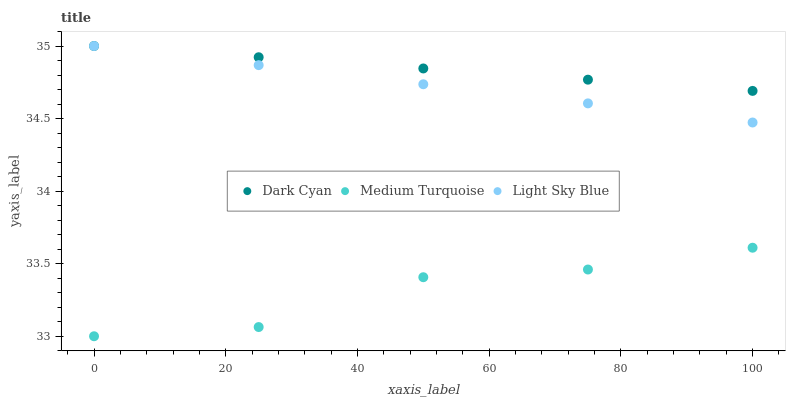Does Medium Turquoise have the minimum area under the curve?
Answer yes or no. Yes. Does Dark Cyan have the maximum area under the curve?
Answer yes or no. Yes. Does Light Sky Blue have the minimum area under the curve?
Answer yes or no. No. Does Light Sky Blue have the maximum area under the curve?
Answer yes or no. No. Is Dark Cyan the smoothest?
Answer yes or no. Yes. Is Medium Turquoise the roughest?
Answer yes or no. Yes. Is Light Sky Blue the smoothest?
Answer yes or no. No. Is Light Sky Blue the roughest?
Answer yes or no. No. Does Medium Turquoise have the lowest value?
Answer yes or no. Yes. Does Light Sky Blue have the lowest value?
Answer yes or no. No. Does Light Sky Blue have the highest value?
Answer yes or no. Yes. Does Medium Turquoise have the highest value?
Answer yes or no. No. Is Medium Turquoise less than Dark Cyan?
Answer yes or no. Yes. Is Dark Cyan greater than Medium Turquoise?
Answer yes or no. Yes. Does Light Sky Blue intersect Dark Cyan?
Answer yes or no. Yes. Is Light Sky Blue less than Dark Cyan?
Answer yes or no. No. Is Light Sky Blue greater than Dark Cyan?
Answer yes or no. No. Does Medium Turquoise intersect Dark Cyan?
Answer yes or no. No. 